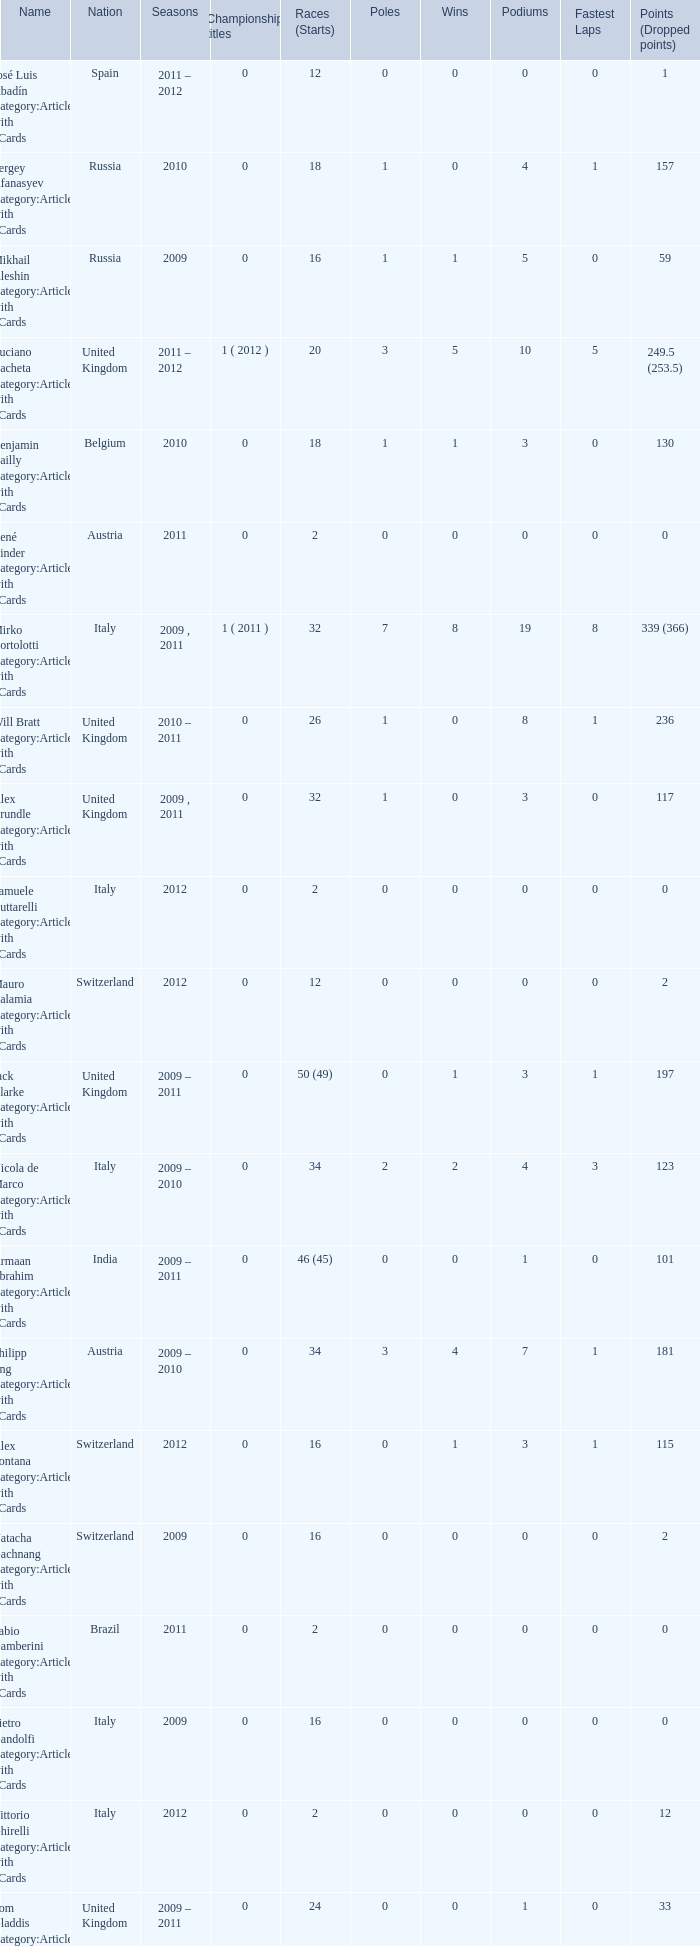Could you parse the entire table as a dict? {'header': ['Name', 'Nation', 'Seasons', 'Championship titles', 'Races (Starts)', 'Poles', 'Wins', 'Podiums', 'Fastest Laps', 'Points (Dropped points)'], 'rows': [['José Luis Abadín Category:Articles with hCards', 'Spain', '2011 – 2012', '0', '12', '0', '0', '0', '0', '1'], ['Sergey Afanasyev Category:Articles with hCards', 'Russia', '2010', '0', '18', '1', '0', '4', '1', '157'], ['Mikhail Aleshin Category:Articles with hCards', 'Russia', '2009', '0', '16', '1', '1', '5', '0', '59'], ['Luciano Bacheta Category:Articles with hCards', 'United Kingdom', '2011 – 2012', '1 ( 2012 )', '20', '3', '5', '10', '5', '249.5 (253.5)'], ['Benjamin Bailly Category:Articles with hCards', 'Belgium', '2010', '0', '18', '1', '1', '3', '0', '130'], ['René Binder Category:Articles with hCards', 'Austria', '2011', '0', '2', '0', '0', '0', '0', '0'], ['Mirko Bortolotti Category:Articles with hCards', 'Italy', '2009 , 2011', '1 ( 2011 )', '32', '7', '8', '19', '8', '339 (366)'], ['Will Bratt Category:Articles with hCards', 'United Kingdom', '2010 – 2011', '0', '26', '1', '0', '8', '1', '236'], ['Alex Brundle Category:Articles with hCards', 'United Kingdom', '2009 , 2011', '0', '32', '1', '0', '3', '0', '117'], ['Samuele Buttarelli Category:Articles with hCards', 'Italy', '2012', '0', '2', '0', '0', '0', '0', '0'], ['Mauro Calamia Category:Articles with hCards', 'Switzerland', '2012', '0', '12', '0', '0', '0', '0', '2'], ['Jack Clarke Category:Articles with hCards', 'United Kingdom', '2009 – 2011', '0', '50 (49)', '0', '1', '3', '1', '197'], ['Nicola de Marco Category:Articles with hCards', 'Italy', '2009 – 2010', '0', '34', '2', '2', '4', '3', '123'], ['Armaan Ebrahim Category:Articles with hCards', 'India', '2009 – 2011', '0', '46 (45)', '0', '0', '1', '0', '101'], ['Philipp Eng Category:Articles with hCards', 'Austria', '2009 – 2010', '0', '34', '3', '4', '7', '1', '181'], ['Alex Fontana Category:Articles with hCards', 'Switzerland', '2012', '0', '16', '0', '1', '3', '1', '115'], ['Natacha Gachnang Category:Articles with hCards', 'Switzerland', '2009', '0', '16', '0', '0', '0', '0', '2'], ['Fabio Gamberini Category:Articles with hCards', 'Brazil', '2011', '0', '2', '0', '0', '0', '0', '0'], ['Pietro Gandolfi Category:Articles with hCards', 'Italy', '2009', '0', '16', '0', '0', '0', '0', '0'], ['Vittorio Ghirelli Category:Articles with hCards', 'Italy', '2012', '0', '2', '0', '0', '0', '0', '12'], ['Tom Gladdis Category:Articles with hCards', 'United Kingdom', '2009 – 2011', '0', '24', '0', '0', '1', '0', '33'], ['Richard Gonda Category:Articles with hCards', 'Slovakia', '2012', '0', '2', '0', '0', '0', '0', '4'], ['Victor Guerin Category:Articles with hCards', 'Brazil', '2012', '0', '2', '0', '0', '0', '0', '2'], ['Ollie Hancock Category:Articles with hCards', 'United Kingdom', '2009', '0', '6', '0', '0', '0', '0', '0'], ['Tobias Hegewald Category:Articles with hCards', 'Germany', '2009 , 2011', '0', '32', '4', '2', '5', '3', '158'], ['Sebastian Hohenthal Category:Articles with hCards', 'Sweden', '2009', '0', '16', '0', '0', '0', '0', '7'], ['Jens Höing Category:Articles with hCards', 'Germany', '2009', '0', '16', '0', '0', '0', '0', '0'], ['Hector Hurst Category:Articles with hCards', 'United Kingdom', '2012', '0', '16', '0', '0', '0', '0', '27'], ['Carlos Iaconelli Category:Articles with hCards', 'Brazil', '2009', '0', '14', '0', '0', '1', '0', '21'], ['Axcil Jefferies Category:Articles with hCards', 'Zimbabwe', '2012', '0', '12 (11)', '0', '0', '0', '0', '17'], ['Johan Jokinen Category:Articles with hCards', 'Denmark', '2010', '0', '6', '0', '0', '1', '1', '21'], ['Julien Jousse Category:Articles with hCards', 'France', '2009', '0', '16', '1', '1', '4', '2', '49'], ['Henri Karjalainen Category:Articles with hCards', 'Finland', '2009', '0', '16', '0', '0', '0', '0', '7'], ['Kourosh Khani Category:Articles with hCards', 'Iran', '2012', '0', '8', '0', '0', '0', '0', '2'], ['Jordan King Category:Articles with hCards', 'United Kingdom', '2011', '0', '6', '0', '0', '0', '0', '17'], ['Natalia Kowalska Category:Articles with hCards', 'Poland', '2010 – 2011', '0', '20', '0', '0', '0', '0', '3'], ['Plamen Kralev Category:Articles with hCards', 'Bulgaria', '2010 – 2012', '0', '50 (49)', '0', '0', '0', '0', '6'], ['Ajith Kumar Category:Articles with hCards', 'India', '2010', '0', '6', '0', '0', '0', '0', '0'], ['Jon Lancaster Category:Articles with hCards', 'United Kingdom', '2011', '0', '2', '0', '0', '0', '0', '14'], ['Benjamin Lariche Category:Articles with hCards', 'France', '2010 – 2011', '0', '34', '0', '0', '0', '0', '48'], ['Mikkel Mac Category:Articles with hCards', 'Denmark', '2011', '0', '16', '0', '0', '0', '0', '23'], ['Mihai Marinescu Category:Articles with hCards', 'Romania', '2010 – 2012', '0', '50', '4', '3', '8', '4', '299'], ['Daniel McKenzie Category:Articles with hCards', 'United Kingdom', '2012', '0', '16', '0', '0', '2', '0', '95'], ['Kevin Mirocha Category:Articles with hCards', 'Poland', '2012', '0', '16', '1', '1', '6', '0', '159.5'], ['Miki Monrás Category:Articles with hCards', 'Spain', '2011', '0', '16', '1', '1', '4', '1', '153'], ['Jason Moore Category:Articles with hCards', 'United Kingdom', '2009', '0', '16 (15)', '0', '0', '0', '0', '3'], ['Sung-Hak Mun Category:Articles with hCards', 'South Korea', '2011', '0', '16 (15)', '0', '0', '0', '0', '0'], ['Jolyon Palmer Category:Articles with hCards', 'United Kingdom', '2009 – 2010', '0', '34 (36)', '5', '5', '10', '3', '245'], ['Miloš Pavlović Category:Articles with hCards', 'Serbia', '2009', '0', '16', '0', '0', '2', '1', '29'], ['Ramón Piñeiro Category:Articles with hCards', 'Spain', '2010 – 2011', '0', '18', '2', '3', '7', '2', '186'], ['Markus Pommer Category:Articles with hCards', 'Germany', '2012', '0', '16', '4', '3', '5', '2', '169'], ['Edoardo Piscopo Category:Articles with hCards', 'Italy', '2009', '0', '14', '0', '0', '0', '0', '19'], ['Paul Rees Category:Articles with hCards', 'United Kingdom', '2010', '0', '8', '0', '0', '0', '0', '18'], ['Ivan Samarin Category:Articles with hCards', 'Russia', '2010', '0', '18', '0', '0', '0', '0', '64'], ['Germán Sánchez Category:Articles with hCards', 'Spain', '2009', '0', '16 (14)', '0', '0', '0', '0', '2'], ['Harald Schlegelmilch Category:Articles with hCards', 'Latvia', '2012', '0', '2', '0', '0', '0', '0', '12'], ['Max Snegirev Category:Articles with hCards', 'Russia', '2011 – 2012', '0', '28', '0', '0', '0', '0', '20'], ['Kelvin Snoeks Category:Articles with hCards', 'Netherlands', '2010 – 2011', '0', '32', '0', '0', '1', '0', '88'], ['Andy Soucek Category:Articles with hCards', 'Spain', '2009', '1 ( 2009 )', '16', '2', '7', '11', '3', '115'], ['Dean Stoneman Category:Articles with hCards', 'United Kingdom', '2010', '1 ( 2010 )', '18', '6', '6', '13', '6', '284'], ['Thiemo Storz Category:Articles with hCards', 'Germany', '2011', '0', '16', '0', '0', '0', '0', '19'], ['Parthiva Sureshwaren Category:Articles with hCards', 'India', '2010 – 2012', '0', '32 (31)', '0', '0', '0', '0', '1'], ['Henry Surtees Category:Articles with hCards', 'United Kingdom', '2009', '0', '8', '1', '0', '1', '0', '8'], ['Ricardo Teixeira Category:Articles with hCards', 'Angola', '2010', '0', '18', '0', '0', '0', '0', '23'], ['Johannes Theobald Category:Articles with hCards', 'Germany', '2010 – 2011', '0', '14', '0', '0', '0', '0', '1'], ['Julian Theobald Category:Articles with hCards', 'Germany', '2010 – 2011', '0', '18', '0', '0', '0', '0', '8'], ['Mathéo Tuscher Category:Articles with hCards', 'Switzerland', '2012', '0', '16', '4', '2', '9', '1', '210'], ['Tristan Vautier Category:Articles with hCards', 'France', '2009', '0', '2', '0', '0', '1', '0', '9'], ['Kazim Vasiliauskas Category:Articles with hCards', 'Lithuania', '2009 – 2010', '0', '34', '3', '2', '10', '4', '198'], ['Robert Wickens Category:Articles with hCards', 'Canada', '2009', '0', '16', '5', '2', '6', '3', '64'], ['Dino Zamparelli Category:Articles with hCards', 'United Kingdom', '2012', '0', '16', '0', '0', '2', '0', '106.5'], ['Christopher Zanella Category:Articles with hCards', 'Switzerland', '2011 – 2012', '0', '32', '3', '4', '14', '5', '385 (401)']]} What was the least amount of wins? 0.0. 